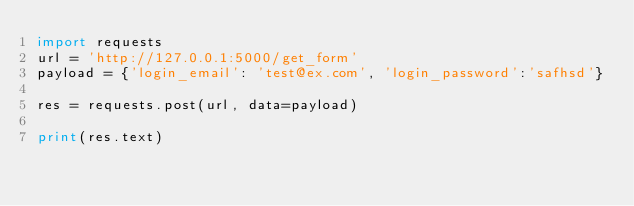<code> <loc_0><loc_0><loc_500><loc_500><_Python_>import requests
url = 'http://127.0.0.1:5000/get_form'
payload = {'login_email': 'test@ex.com', 'login_password':'safhsd'}

res = requests.post(url, data=payload)

print(res.text)
</code> 